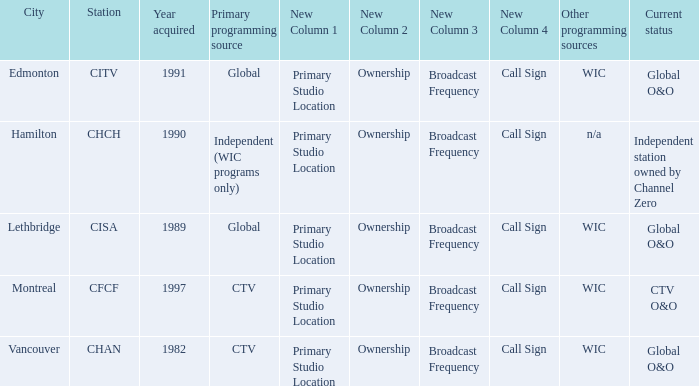Parse the table in full. {'header': ['City', 'Station', 'Year acquired', 'Primary programming source', 'New Column 1', 'New Column 2', 'New Column 3', 'New Column 4', 'Other programming sources', 'Current status'], 'rows': [['Edmonton', 'CITV', '1991', 'Global', 'Primary Studio Location', 'Ownership', 'Broadcast Frequency', 'Call Sign', 'WIC', 'Global O&O'], ['Hamilton', 'CHCH', '1990', 'Independent (WIC programs only)', 'Primary Studio Location', 'Ownership', 'Broadcast Frequency', 'Call Sign', 'n/a', 'Independent station owned by Channel Zero'], ['Lethbridge', 'CISA', '1989', 'Global', 'Primary Studio Location', 'Ownership', 'Broadcast Frequency', 'Call Sign', 'WIC', 'Global O&O'], ['Montreal', 'CFCF', '1997', 'CTV', 'Primary Studio Location', 'Ownership', 'Broadcast Frequency', 'Call Sign', 'WIC', 'CTV O&O'], ['Vancouver', 'CHAN', '1982', 'CTV', 'Primary Studio Location', 'Ownership', 'Broadcast Frequency', 'Call Sign', 'WIC', 'Global O&O']]} Where is citv located Edmonton. 